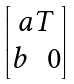<formula> <loc_0><loc_0><loc_500><loc_500>\begin{bmatrix} a T \\ \begin{matrix} b & 0 \end{matrix} \end{bmatrix}</formula> 